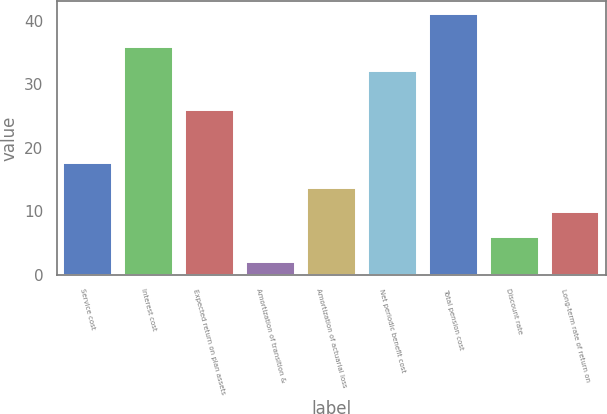Convert chart to OTSL. <chart><loc_0><loc_0><loc_500><loc_500><bar_chart><fcel>Service cost<fcel>Interest cost<fcel>Expected return on plan assets<fcel>Amortization of transition &<fcel>Amortization of actuarial loss<fcel>Net periodic benefit cost<fcel>Total pension cost<fcel>Discount rate<fcel>Long-term rate of return on<nl><fcel>17.6<fcel>35.9<fcel>26<fcel>2<fcel>13.7<fcel>32<fcel>41<fcel>5.9<fcel>9.8<nl></chart> 